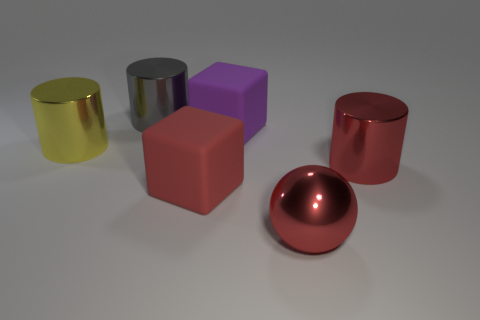Add 1 large red shiny spheres. How many objects exist? 7 Subtract all yellow cylinders. How many cylinders are left? 2 Subtract 1 cylinders. How many cylinders are left? 2 Subtract all cyan cylinders. Subtract all purple balls. How many cylinders are left? 3 Subtract all large green things. Subtract all purple things. How many objects are left? 5 Add 1 gray shiny things. How many gray shiny things are left? 2 Add 2 big cylinders. How many big cylinders exist? 5 Subtract 0 purple cylinders. How many objects are left? 6 Subtract all blocks. How many objects are left? 4 